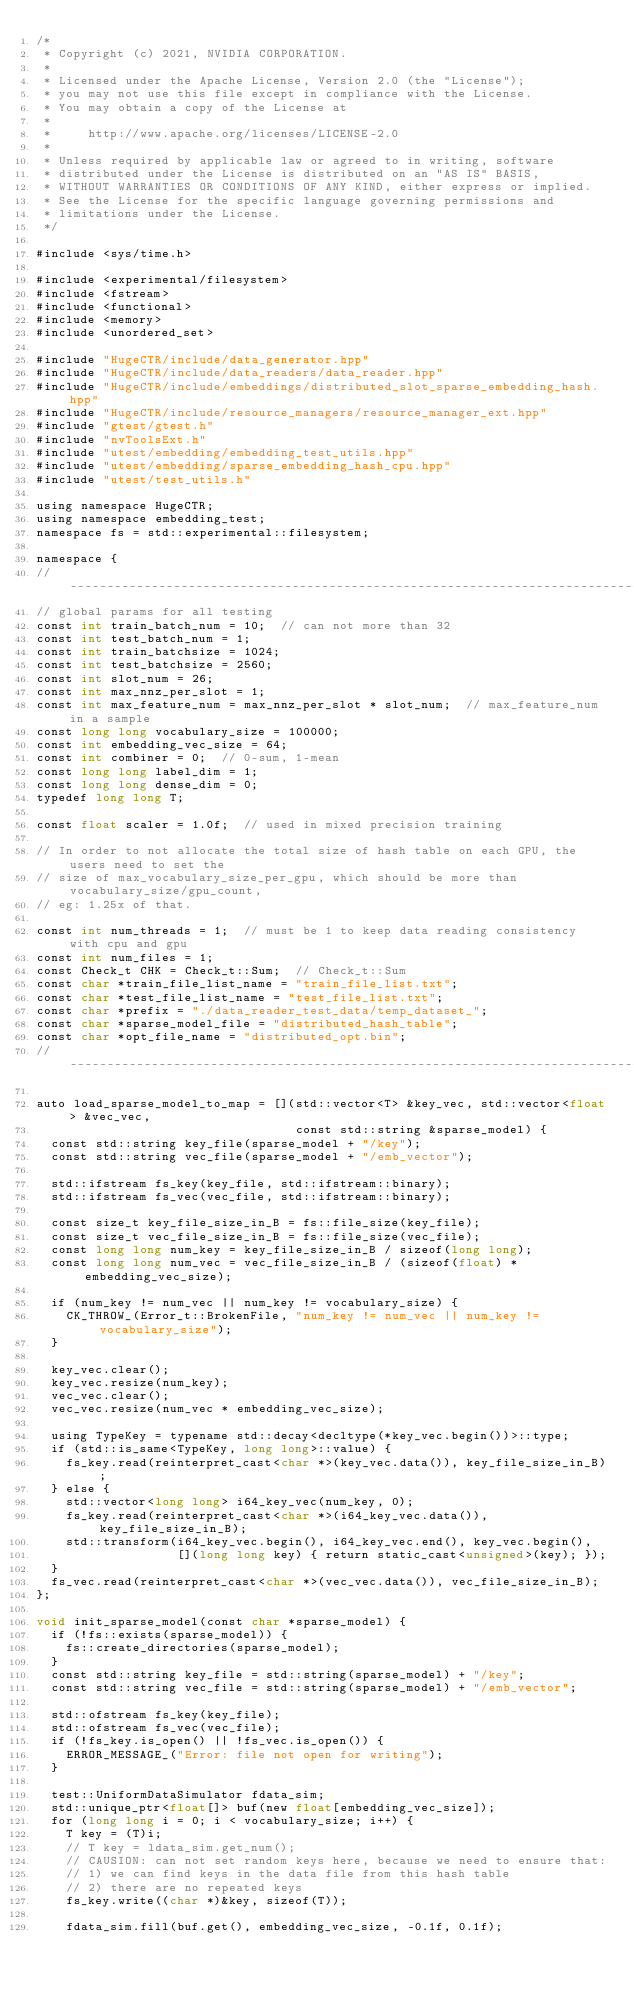Convert code to text. <code><loc_0><loc_0><loc_500><loc_500><_Cuda_>/*
 * Copyright (c) 2021, NVIDIA CORPORATION.
 *
 * Licensed under the Apache License, Version 2.0 (the "License");
 * you may not use this file except in compliance with the License.
 * You may obtain a copy of the License at
 *
 *     http://www.apache.org/licenses/LICENSE-2.0
 *
 * Unless required by applicable law or agreed to in writing, software
 * distributed under the License is distributed on an "AS IS" BASIS,
 * WITHOUT WARRANTIES OR CONDITIONS OF ANY KIND, either express or implied.
 * See the License for the specific language governing permissions and
 * limitations under the License.
 */

#include <sys/time.h>

#include <experimental/filesystem>
#include <fstream>
#include <functional>
#include <memory>
#include <unordered_set>

#include "HugeCTR/include/data_generator.hpp"
#include "HugeCTR/include/data_readers/data_reader.hpp"
#include "HugeCTR/include/embeddings/distributed_slot_sparse_embedding_hash.hpp"
#include "HugeCTR/include/resource_managers/resource_manager_ext.hpp"
#include "gtest/gtest.h"
#include "nvToolsExt.h"
#include "utest/embedding/embedding_test_utils.hpp"
#include "utest/embedding/sparse_embedding_hash_cpu.hpp"
#include "utest/test_utils.h"

using namespace HugeCTR;
using namespace embedding_test;
namespace fs = std::experimental::filesystem;

namespace {
//---------------------------------------------------------------------------------------
// global params for all testing
const int train_batch_num = 10;  // can not more than 32
const int test_batch_num = 1;
const int train_batchsize = 1024;
const int test_batchsize = 2560;
const int slot_num = 26;
const int max_nnz_per_slot = 1;
const int max_feature_num = max_nnz_per_slot * slot_num;  // max_feature_num in a sample
const long long vocabulary_size = 100000;
const int embedding_vec_size = 64;
const int combiner = 0;  // 0-sum, 1-mean
const long long label_dim = 1;
const long long dense_dim = 0;
typedef long long T;

const float scaler = 1.0f;  // used in mixed precision training

// In order to not allocate the total size of hash table on each GPU, the users need to set the
// size of max_vocabulary_size_per_gpu, which should be more than vocabulary_size/gpu_count,
// eg: 1.25x of that.

const int num_threads = 1;  // must be 1 to keep data reading consistency with cpu and gpu
const int num_files = 1;
const Check_t CHK = Check_t::Sum;  // Check_t::Sum
const char *train_file_list_name = "train_file_list.txt";
const char *test_file_list_name = "test_file_list.txt";
const char *prefix = "./data_reader_test_data/temp_dataset_";
const char *sparse_model_file = "distributed_hash_table";
const char *opt_file_name = "distributed_opt.bin";
//-----------------------------------------------------------------------------------------

auto load_sparse_model_to_map = [](std::vector<T> &key_vec, std::vector<float> &vec_vec,
                                   const std::string &sparse_model) {
  const std::string key_file(sparse_model + "/key");
  const std::string vec_file(sparse_model + "/emb_vector");

  std::ifstream fs_key(key_file, std::ifstream::binary);
  std::ifstream fs_vec(vec_file, std::ifstream::binary);

  const size_t key_file_size_in_B = fs::file_size(key_file);
  const size_t vec_file_size_in_B = fs::file_size(vec_file);
  const long long num_key = key_file_size_in_B / sizeof(long long);
  const long long num_vec = vec_file_size_in_B / (sizeof(float) * embedding_vec_size);

  if (num_key != num_vec || num_key != vocabulary_size) {
    CK_THROW_(Error_t::BrokenFile, "num_key != num_vec || num_key != vocabulary_size");
  }

  key_vec.clear();
  key_vec.resize(num_key);
  vec_vec.clear();
  vec_vec.resize(num_vec * embedding_vec_size);

  using TypeKey = typename std::decay<decltype(*key_vec.begin())>::type;
  if (std::is_same<TypeKey, long long>::value) {
    fs_key.read(reinterpret_cast<char *>(key_vec.data()), key_file_size_in_B);
  } else {
    std::vector<long long> i64_key_vec(num_key, 0);
    fs_key.read(reinterpret_cast<char *>(i64_key_vec.data()), key_file_size_in_B);
    std::transform(i64_key_vec.begin(), i64_key_vec.end(), key_vec.begin(),
                   [](long long key) { return static_cast<unsigned>(key); });
  }
  fs_vec.read(reinterpret_cast<char *>(vec_vec.data()), vec_file_size_in_B);
};

void init_sparse_model(const char *sparse_model) {
  if (!fs::exists(sparse_model)) {
    fs::create_directories(sparse_model);
  }
  const std::string key_file = std::string(sparse_model) + "/key";
  const std::string vec_file = std::string(sparse_model) + "/emb_vector";

  std::ofstream fs_key(key_file);
  std::ofstream fs_vec(vec_file);
  if (!fs_key.is_open() || !fs_vec.is_open()) {
    ERROR_MESSAGE_("Error: file not open for writing");
  }

  test::UniformDataSimulator fdata_sim;
  std::unique_ptr<float[]> buf(new float[embedding_vec_size]);
  for (long long i = 0; i < vocabulary_size; i++) {
    T key = (T)i;
    // T key = ldata_sim.get_num();
    // CAUSION: can not set random keys here, because we need to ensure that:
    // 1) we can find keys in the data file from this hash table
    // 2) there are no repeated keys
    fs_key.write((char *)&key, sizeof(T));

    fdata_sim.fill(buf.get(), embedding_vec_size, -0.1f, 0.1f);</code> 